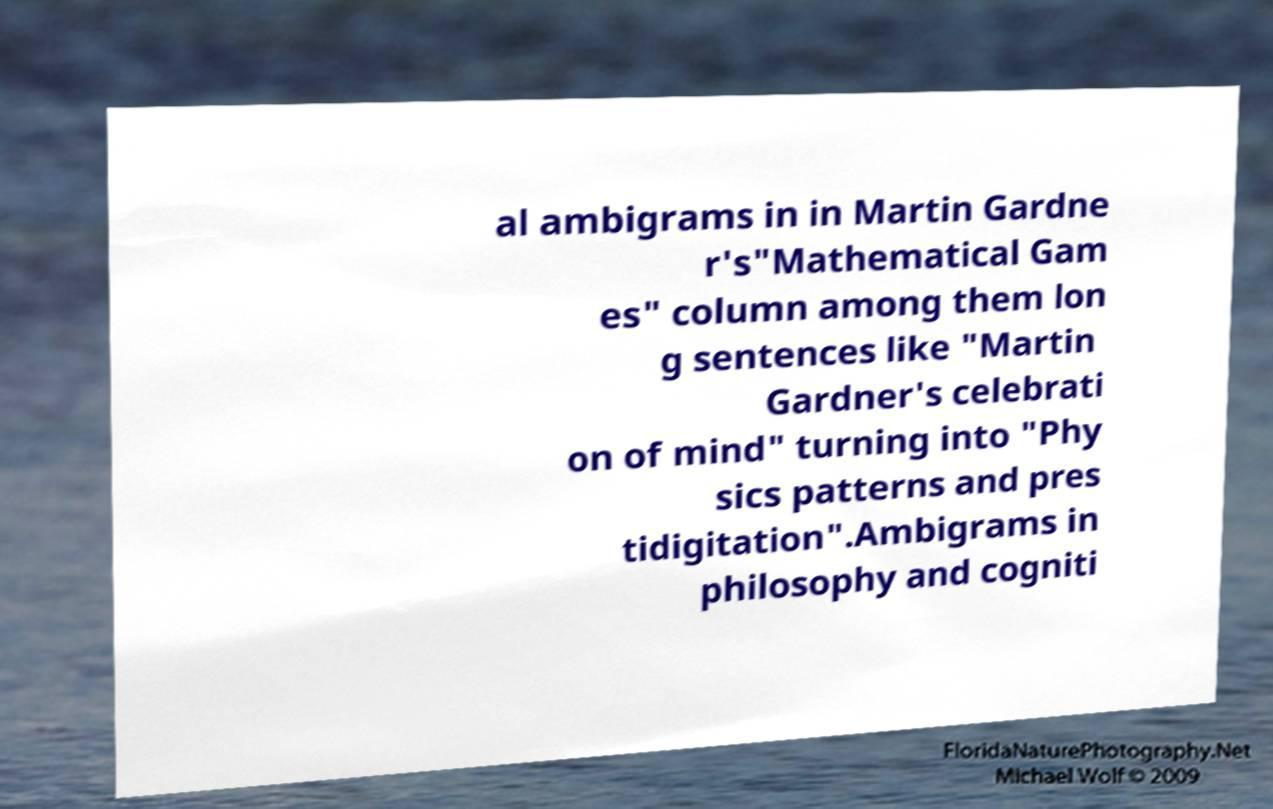Please identify and transcribe the text found in this image. al ambigrams in in Martin Gardne r's"Mathematical Gam es" column among them lon g sentences like "Martin Gardner's celebrati on of mind" turning into "Phy sics patterns and pres tidigitation".Ambigrams in philosophy and cogniti 